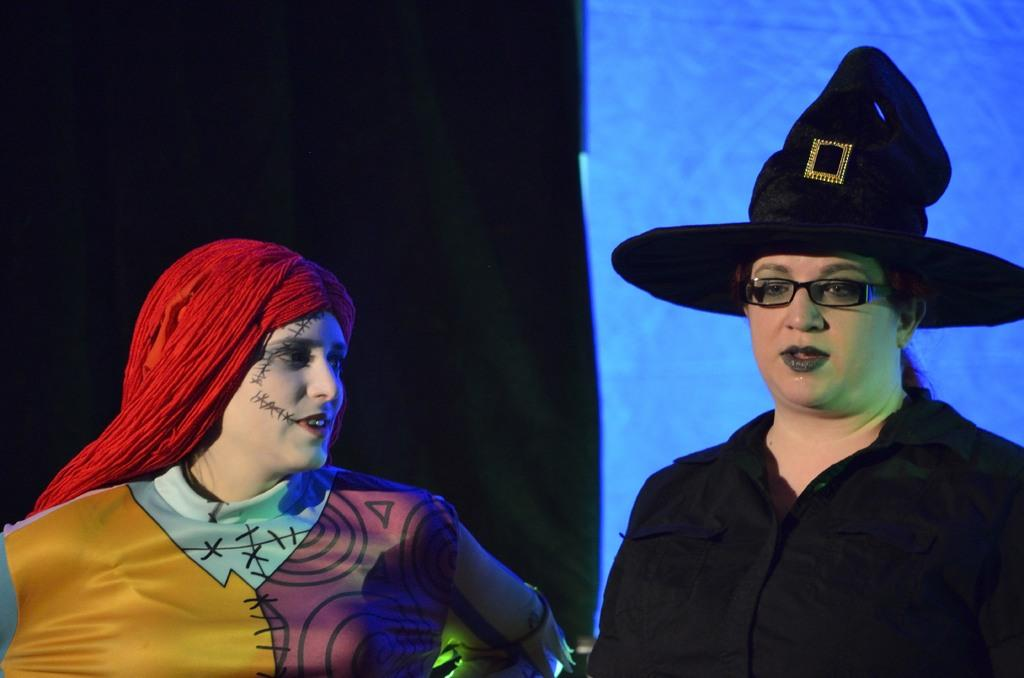How many people are in the image? There are two persons in the image. What can be said about the hair color of one of the persons? One person has red hair. What accessory is worn by the other person? The other person is wearing a black hat. What additional feature can be observed on the person wearing the black hat? The person wearing the black hat is also wearing spectacles. Who is the owner of the spiders in the image? There are no spiders present in the image. 